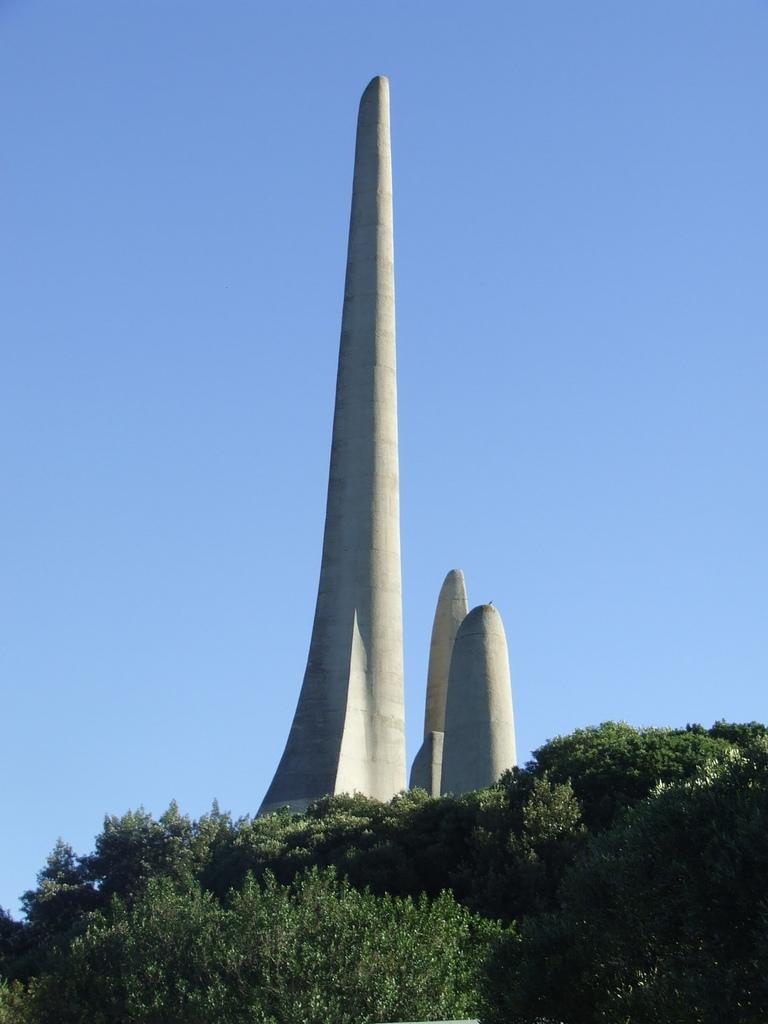In one or two sentences, can you explain what this image depicts? In this image there is a big cement pillar in the middle. Beside it there are two other small pillars. At the bottom there are plants. At the top there is sky. 